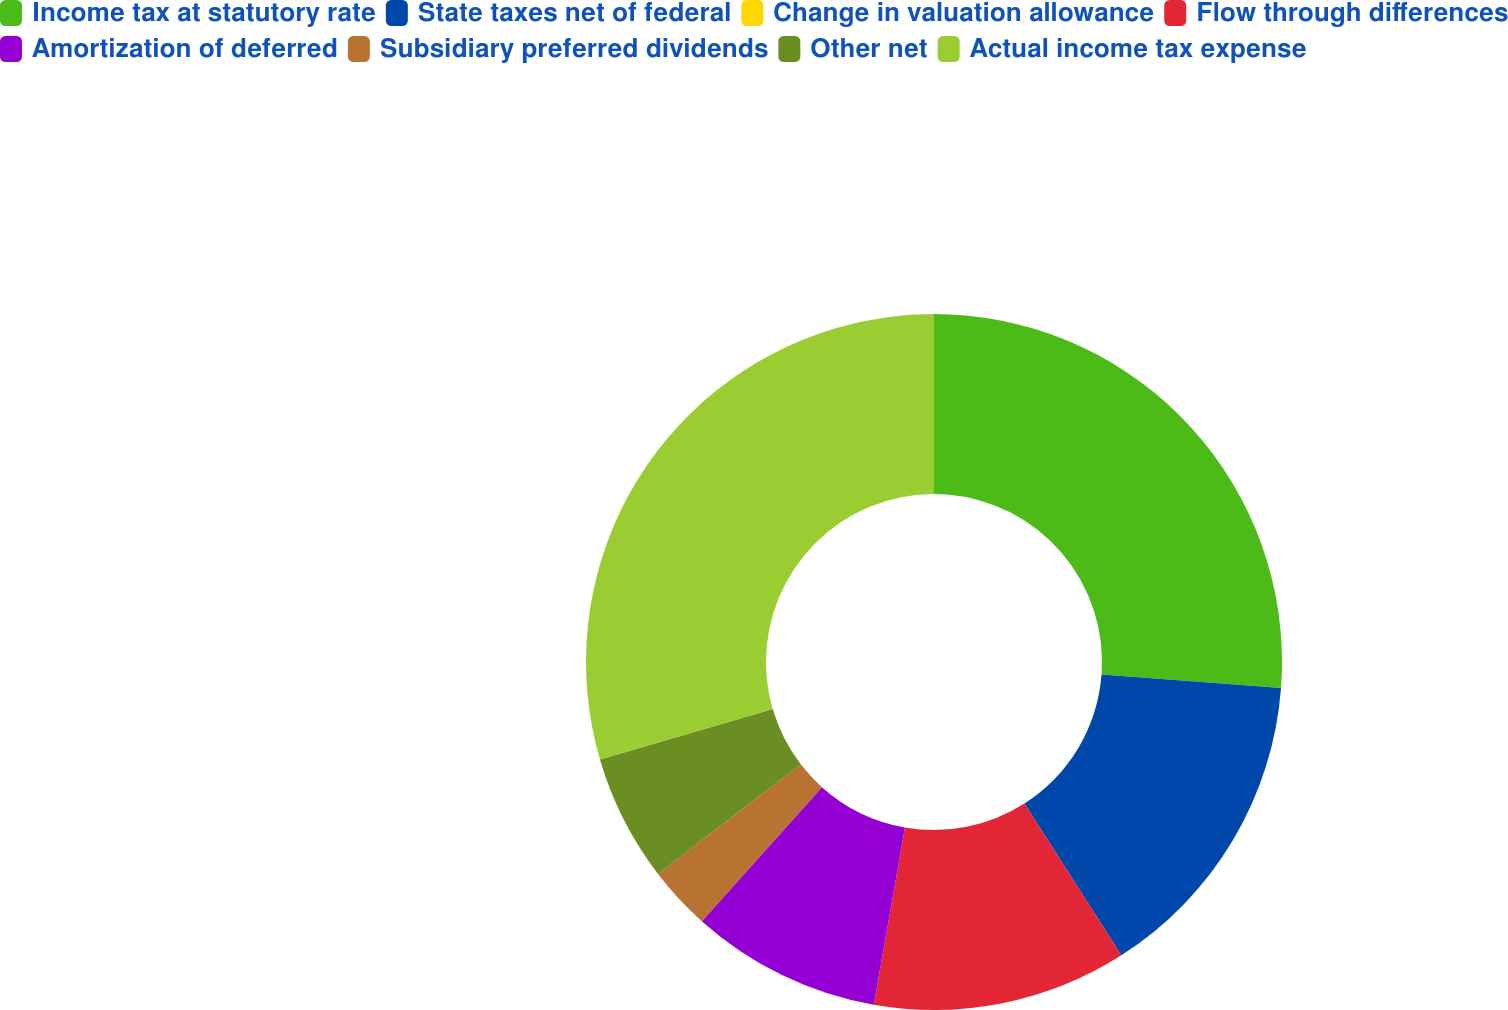Convert chart to OTSL. <chart><loc_0><loc_0><loc_500><loc_500><pie_chart><fcel>Income tax at statutory rate<fcel>State taxes net of federal<fcel>Change in valuation allowance<fcel>Flow through differences<fcel>Amortization of deferred<fcel>Subsidiary preferred dividends<fcel>Other net<fcel>Actual income tax expense<nl><fcel>26.19%<fcel>14.76%<fcel>0.0%<fcel>11.81%<fcel>8.86%<fcel>2.95%<fcel>5.9%<fcel>29.52%<nl></chart> 